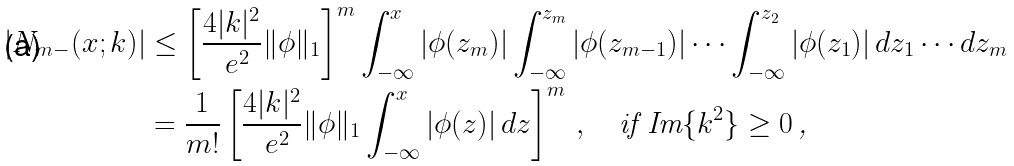Convert formula to latex. <formula><loc_0><loc_0><loc_500><loc_500>| N _ { m - } ( x ; k ) | & \leq \left [ \frac { 4 | k | ^ { 2 } } { \ e ^ { 2 } } \| \phi \| _ { 1 } \right ] ^ { m } \int _ { - \infty } ^ { x } | \phi ( z _ { m } ) | \int _ { - \infty } ^ { z _ { m } } | \phi ( z _ { m - 1 } ) | \cdots \int _ { - \infty } ^ { z _ { 2 } } | \phi ( z _ { 1 } ) | \, d z _ { 1 } \cdots d z _ { m } \\ & = \frac { 1 } { m ! } \left [ \frac { 4 | k | ^ { 2 } } { \ e ^ { 2 } } \| \phi \| _ { 1 } \int _ { - \infty } ^ { x } | \phi ( z ) | \, d z \right ] ^ { m } \, , \quad \text {if $\text {Im}\{k^{2}\}\geq 0$\,,}</formula> 